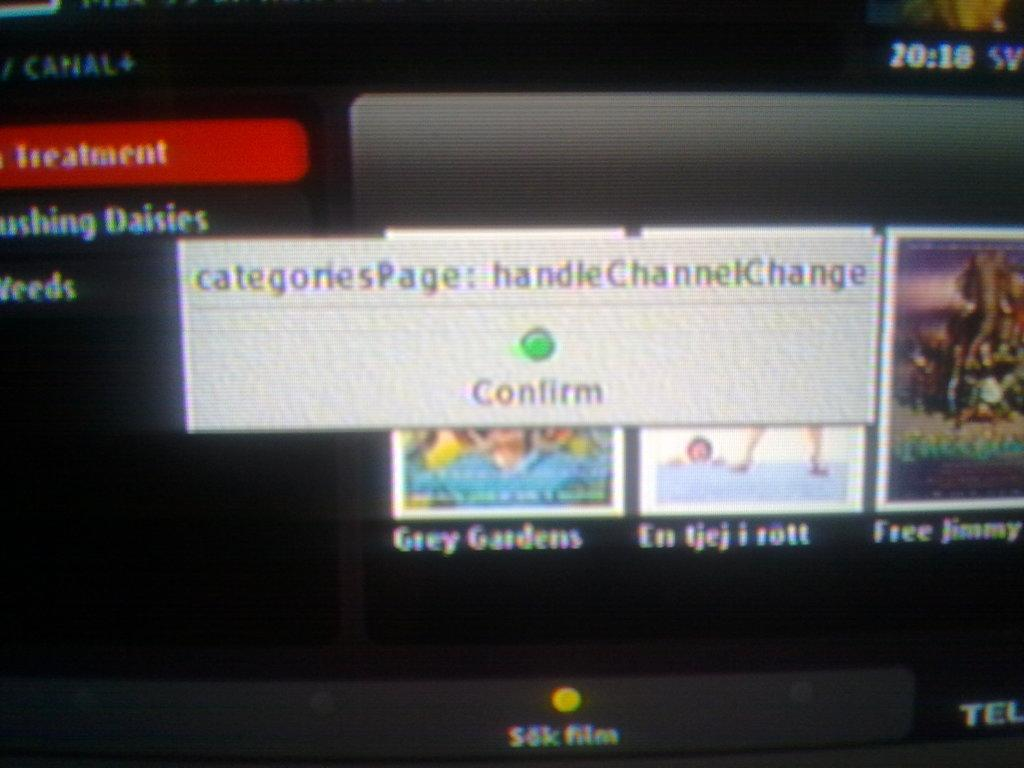Provide a one-sentence caption for the provided image. The message asks to confirm the categoriesPage: handleChannelChange. 